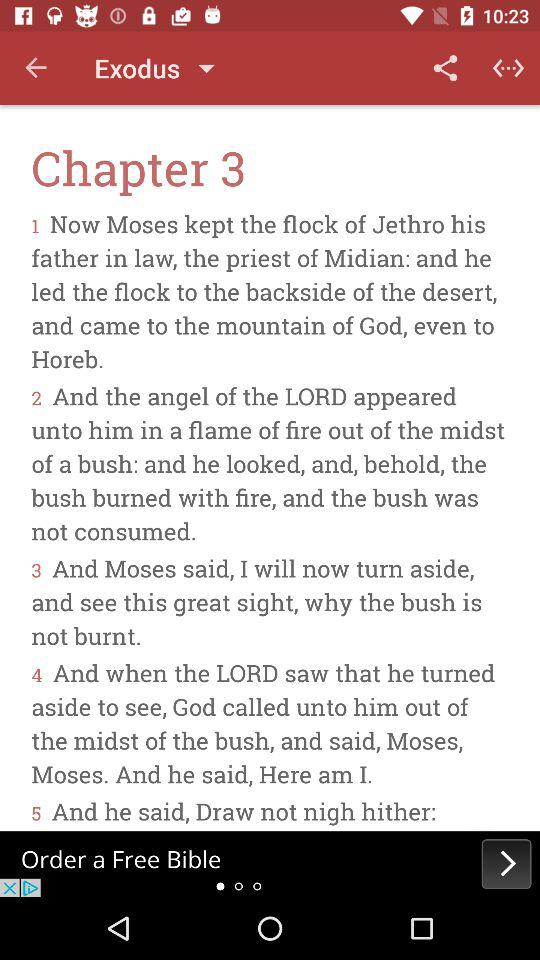What's the book name? The book name is "Exodus". 